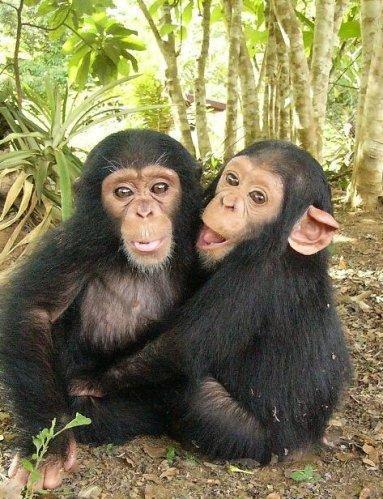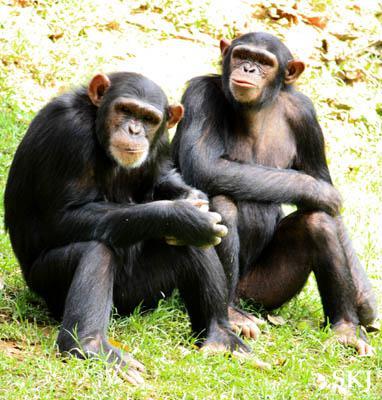The first image is the image on the left, the second image is the image on the right. For the images shown, is this caption "There is two chimpanzees in the right image laying down." true? Answer yes or no. No. The first image is the image on the left, the second image is the image on the right. Analyze the images presented: Is the assertion "An image shows a pair of same-sized chimps in a hugging pose." valid? Answer yes or no. Yes. 